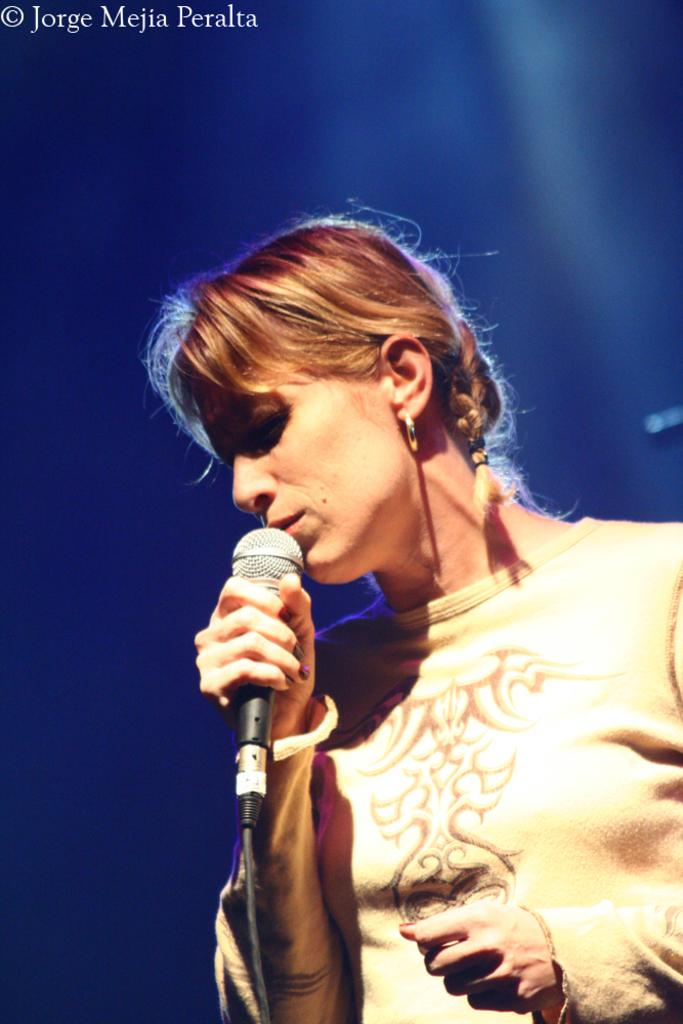Who is the main subject in the image? There is a lady in the image. Where is the lady positioned in the image? The lady is standing on the right side of the image. What is the lady holding in the image? The lady is holding a mic. What is the riddle that the lady is trying to solve in the image? There is no riddle present in the image; the lady is simply holding a mic. How many soldiers are visible in the image? There are no soldiers or army members present in the image. 